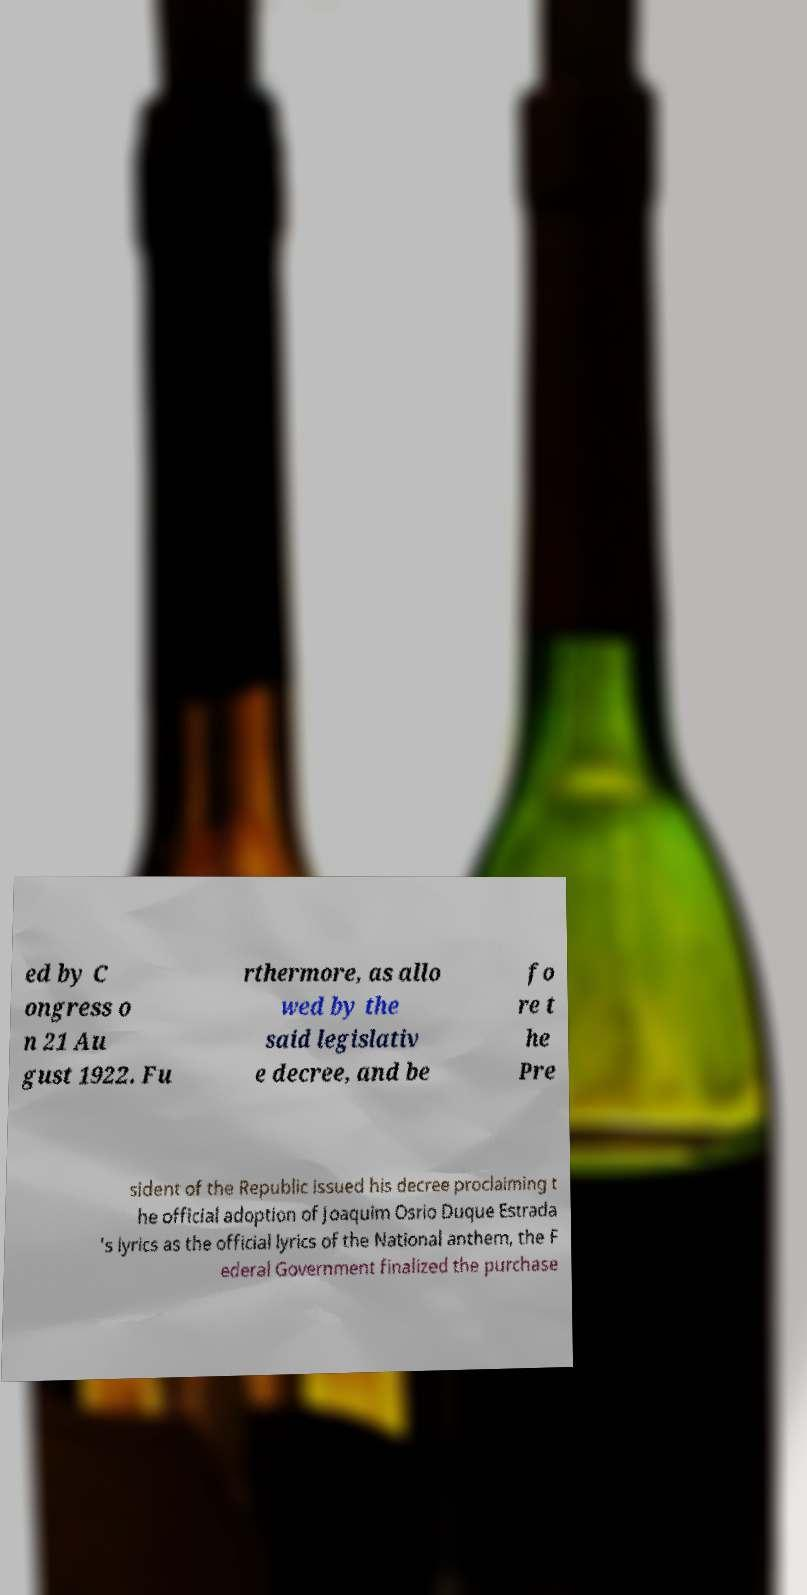Please read and relay the text visible in this image. What does it say? ed by C ongress o n 21 Au gust 1922. Fu rthermore, as allo wed by the said legislativ e decree, and be fo re t he Pre sident of the Republic issued his decree proclaiming t he official adoption of Joaquim Osrio Duque Estrada 's lyrics as the official lyrics of the National anthem, the F ederal Government finalized the purchase 